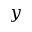<formula> <loc_0><loc_0><loc_500><loc_500>y</formula> 